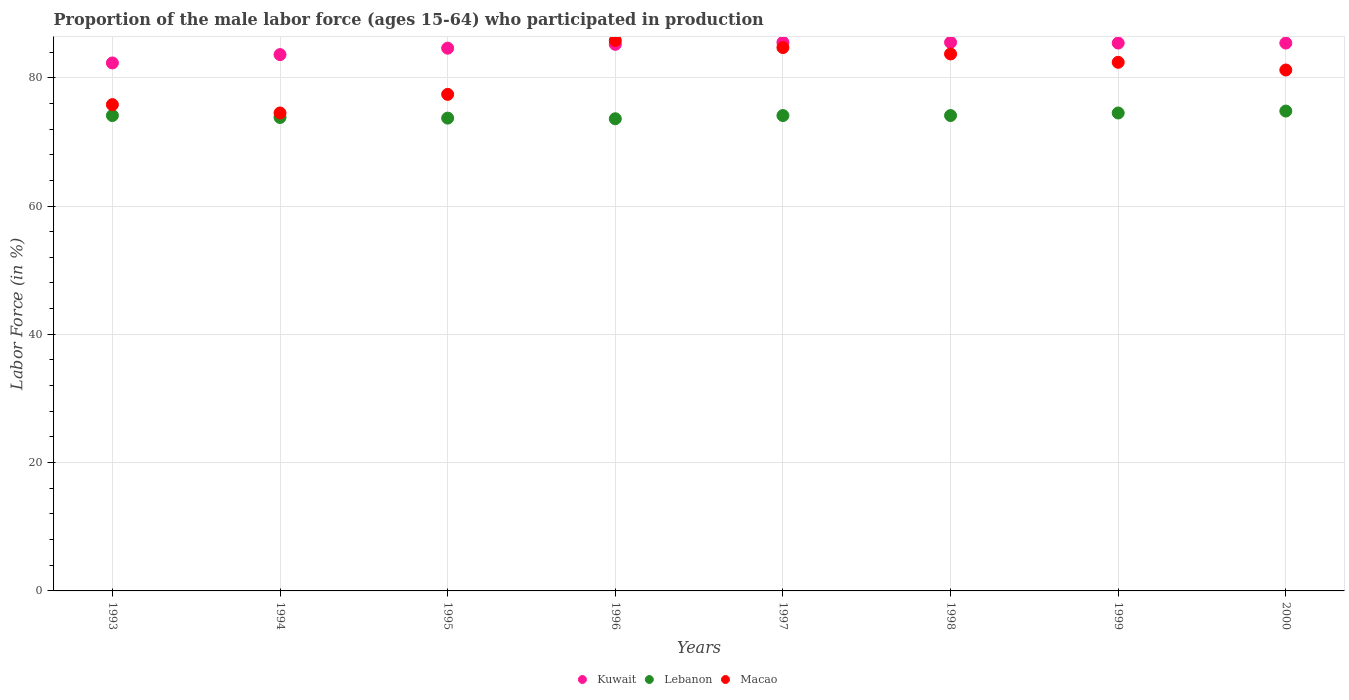How many different coloured dotlines are there?
Your response must be concise. 3. Is the number of dotlines equal to the number of legend labels?
Your response must be concise. Yes. What is the proportion of the male labor force who participated in production in Lebanon in 1998?
Your answer should be very brief. 74.1. Across all years, what is the maximum proportion of the male labor force who participated in production in Macao?
Your answer should be compact. 85.8. Across all years, what is the minimum proportion of the male labor force who participated in production in Kuwait?
Your answer should be compact. 82.3. In which year was the proportion of the male labor force who participated in production in Kuwait minimum?
Your response must be concise. 1993. What is the total proportion of the male labor force who participated in production in Macao in the graph?
Your response must be concise. 645.5. What is the difference between the proportion of the male labor force who participated in production in Lebanon in 1994 and that in 1995?
Your response must be concise. 0.1. What is the average proportion of the male labor force who participated in production in Macao per year?
Your answer should be compact. 80.69. In the year 1995, what is the difference between the proportion of the male labor force who participated in production in Kuwait and proportion of the male labor force who participated in production in Lebanon?
Provide a short and direct response. 10.9. What is the ratio of the proportion of the male labor force who participated in production in Kuwait in 1993 to that in 1994?
Provide a succinct answer. 0.98. Is the difference between the proportion of the male labor force who participated in production in Kuwait in 1994 and 1998 greater than the difference between the proportion of the male labor force who participated in production in Lebanon in 1994 and 1998?
Keep it short and to the point. No. What is the difference between the highest and the second highest proportion of the male labor force who participated in production in Kuwait?
Ensure brevity in your answer.  0. What is the difference between the highest and the lowest proportion of the male labor force who participated in production in Lebanon?
Offer a terse response. 1.2. Is the sum of the proportion of the male labor force who participated in production in Macao in 1996 and 1997 greater than the maximum proportion of the male labor force who participated in production in Kuwait across all years?
Provide a short and direct response. Yes. Is it the case that in every year, the sum of the proportion of the male labor force who participated in production in Macao and proportion of the male labor force who participated in production in Lebanon  is greater than the proportion of the male labor force who participated in production in Kuwait?
Keep it short and to the point. Yes. Does the proportion of the male labor force who participated in production in Macao monotonically increase over the years?
Offer a terse response. No. Is the proportion of the male labor force who participated in production in Macao strictly greater than the proportion of the male labor force who participated in production in Kuwait over the years?
Keep it short and to the point. No. How many dotlines are there?
Offer a very short reply. 3. How many years are there in the graph?
Your response must be concise. 8. What is the difference between two consecutive major ticks on the Y-axis?
Ensure brevity in your answer.  20. Are the values on the major ticks of Y-axis written in scientific E-notation?
Offer a terse response. No. Does the graph contain any zero values?
Your answer should be compact. No. Does the graph contain grids?
Offer a terse response. Yes. Where does the legend appear in the graph?
Provide a succinct answer. Bottom center. What is the title of the graph?
Your answer should be compact. Proportion of the male labor force (ages 15-64) who participated in production. Does "Heavily indebted poor countries" appear as one of the legend labels in the graph?
Provide a succinct answer. No. What is the label or title of the X-axis?
Your answer should be compact. Years. What is the Labor Force (in %) of Kuwait in 1993?
Your response must be concise. 82.3. What is the Labor Force (in %) in Lebanon in 1993?
Keep it short and to the point. 74.1. What is the Labor Force (in %) in Macao in 1993?
Offer a terse response. 75.8. What is the Labor Force (in %) of Kuwait in 1994?
Keep it short and to the point. 83.6. What is the Labor Force (in %) in Lebanon in 1994?
Make the answer very short. 73.8. What is the Labor Force (in %) of Macao in 1994?
Your response must be concise. 74.5. What is the Labor Force (in %) in Kuwait in 1995?
Offer a terse response. 84.6. What is the Labor Force (in %) in Lebanon in 1995?
Provide a succinct answer. 73.7. What is the Labor Force (in %) in Macao in 1995?
Make the answer very short. 77.4. What is the Labor Force (in %) in Kuwait in 1996?
Provide a succinct answer. 85.2. What is the Labor Force (in %) in Lebanon in 1996?
Offer a very short reply. 73.6. What is the Labor Force (in %) in Macao in 1996?
Offer a very short reply. 85.8. What is the Labor Force (in %) of Kuwait in 1997?
Your answer should be very brief. 85.5. What is the Labor Force (in %) in Lebanon in 1997?
Provide a succinct answer. 74.1. What is the Labor Force (in %) in Macao in 1997?
Make the answer very short. 84.7. What is the Labor Force (in %) in Kuwait in 1998?
Offer a very short reply. 85.5. What is the Labor Force (in %) in Lebanon in 1998?
Offer a very short reply. 74.1. What is the Labor Force (in %) of Macao in 1998?
Your answer should be compact. 83.7. What is the Labor Force (in %) in Kuwait in 1999?
Your answer should be very brief. 85.4. What is the Labor Force (in %) in Lebanon in 1999?
Make the answer very short. 74.5. What is the Labor Force (in %) of Macao in 1999?
Your answer should be very brief. 82.4. What is the Labor Force (in %) in Kuwait in 2000?
Make the answer very short. 85.4. What is the Labor Force (in %) of Lebanon in 2000?
Your response must be concise. 74.8. What is the Labor Force (in %) in Macao in 2000?
Make the answer very short. 81.2. Across all years, what is the maximum Labor Force (in %) of Kuwait?
Offer a very short reply. 85.5. Across all years, what is the maximum Labor Force (in %) of Lebanon?
Offer a terse response. 74.8. Across all years, what is the maximum Labor Force (in %) of Macao?
Make the answer very short. 85.8. Across all years, what is the minimum Labor Force (in %) of Kuwait?
Offer a very short reply. 82.3. Across all years, what is the minimum Labor Force (in %) in Lebanon?
Offer a very short reply. 73.6. Across all years, what is the minimum Labor Force (in %) in Macao?
Keep it short and to the point. 74.5. What is the total Labor Force (in %) in Kuwait in the graph?
Your answer should be very brief. 677.5. What is the total Labor Force (in %) in Lebanon in the graph?
Ensure brevity in your answer.  592.7. What is the total Labor Force (in %) in Macao in the graph?
Make the answer very short. 645.5. What is the difference between the Labor Force (in %) of Kuwait in 1993 and that in 1994?
Your response must be concise. -1.3. What is the difference between the Labor Force (in %) of Lebanon in 1993 and that in 1995?
Offer a terse response. 0.4. What is the difference between the Labor Force (in %) in Kuwait in 1993 and that in 1996?
Provide a short and direct response. -2.9. What is the difference between the Labor Force (in %) of Kuwait in 1993 and that in 1997?
Offer a very short reply. -3.2. What is the difference between the Labor Force (in %) of Lebanon in 1993 and that in 1997?
Provide a short and direct response. 0. What is the difference between the Labor Force (in %) in Kuwait in 1993 and that in 1998?
Give a very brief answer. -3.2. What is the difference between the Labor Force (in %) of Lebanon in 1993 and that in 1998?
Keep it short and to the point. 0. What is the difference between the Labor Force (in %) of Kuwait in 1993 and that in 2000?
Offer a very short reply. -3.1. What is the difference between the Labor Force (in %) of Macao in 1993 and that in 2000?
Provide a short and direct response. -5.4. What is the difference between the Labor Force (in %) of Lebanon in 1994 and that in 1996?
Give a very brief answer. 0.2. What is the difference between the Labor Force (in %) in Macao in 1994 and that in 1997?
Provide a succinct answer. -10.2. What is the difference between the Labor Force (in %) in Kuwait in 1994 and that in 1998?
Your response must be concise. -1.9. What is the difference between the Labor Force (in %) in Lebanon in 1994 and that in 1999?
Your answer should be very brief. -0.7. What is the difference between the Labor Force (in %) of Macao in 1994 and that in 1999?
Provide a short and direct response. -7.9. What is the difference between the Labor Force (in %) in Kuwait in 1994 and that in 2000?
Your answer should be very brief. -1.8. What is the difference between the Labor Force (in %) in Macao in 1994 and that in 2000?
Keep it short and to the point. -6.7. What is the difference between the Labor Force (in %) in Kuwait in 1995 and that in 1997?
Offer a terse response. -0.9. What is the difference between the Labor Force (in %) of Lebanon in 1995 and that in 1997?
Give a very brief answer. -0.4. What is the difference between the Labor Force (in %) in Macao in 1995 and that in 1997?
Your response must be concise. -7.3. What is the difference between the Labor Force (in %) of Kuwait in 1995 and that in 1998?
Offer a terse response. -0.9. What is the difference between the Labor Force (in %) in Lebanon in 1995 and that in 1998?
Provide a succinct answer. -0.4. What is the difference between the Labor Force (in %) in Macao in 1995 and that in 1998?
Provide a short and direct response. -6.3. What is the difference between the Labor Force (in %) of Kuwait in 1995 and that in 1999?
Your answer should be very brief. -0.8. What is the difference between the Labor Force (in %) of Macao in 1995 and that in 1999?
Provide a succinct answer. -5. What is the difference between the Labor Force (in %) in Macao in 1995 and that in 2000?
Your response must be concise. -3.8. What is the difference between the Labor Force (in %) of Lebanon in 1996 and that in 1997?
Provide a succinct answer. -0.5. What is the difference between the Labor Force (in %) in Kuwait in 1996 and that in 1999?
Ensure brevity in your answer.  -0.2. What is the difference between the Labor Force (in %) of Lebanon in 1996 and that in 1999?
Provide a succinct answer. -0.9. What is the difference between the Labor Force (in %) of Macao in 1996 and that in 1999?
Make the answer very short. 3.4. What is the difference between the Labor Force (in %) in Kuwait in 1996 and that in 2000?
Your answer should be very brief. -0.2. What is the difference between the Labor Force (in %) of Lebanon in 1996 and that in 2000?
Make the answer very short. -1.2. What is the difference between the Labor Force (in %) in Macao in 1996 and that in 2000?
Give a very brief answer. 4.6. What is the difference between the Labor Force (in %) in Kuwait in 1997 and that in 1999?
Make the answer very short. 0.1. What is the difference between the Labor Force (in %) of Lebanon in 1997 and that in 1999?
Offer a terse response. -0.4. What is the difference between the Labor Force (in %) of Macao in 1997 and that in 1999?
Offer a very short reply. 2.3. What is the difference between the Labor Force (in %) of Lebanon in 1997 and that in 2000?
Provide a short and direct response. -0.7. What is the difference between the Labor Force (in %) in Macao in 1997 and that in 2000?
Offer a very short reply. 3.5. What is the difference between the Labor Force (in %) in Kuwait in 1998 and that in 1999?
Your response must be concise. 0.1. What is the difference between the Labor Force (in %) of Macao in 1998 and that in 1999?
Make the answer very short. 1.3. What is the difference between the Labor Force (in %) of Kuwait in 1998 and that in 2000?
Make the answer very short. 0.1. What is the difference between the Labor Force (in %) of Lebanon in 1999 and that in 2000?
Provide a short and direct response. -0.3. What is the difference between the Labor Force (in %) of Kuwait in 1993 and the Labor Force (in %) of Lebanon in 1995?
Make the answer very short. 8.6. What is the difference between the Labor Force (in %) in Lebanon in 1993 and the Labor Force (in %) in Macao in 1995?
Provide a succinct answer. -3.3. What is the difference between the Labor Force (in %) in Kuwait in 1993 and the Labor Force (in %) in Macao in 1996?
Offer a terse response. -3.5. What is the difference between the Labor Force (in %) of Lebanon in 1993 and the Labor Force (in %) of Macao in 1996?
Provide a succinct answer. -11.7. What is the difference between the Labor Force (in %) of Kuwait in 1993 and the Labor Force (in %) of Lebanon in 1997?
Keep it short and to the point. 8.2. What is the difference between the Labor Force (in %) of Lebanon in 1993 and the Labor Force (in %) of Macao in 1997?
Offer a terse response. -10.6. What is the difference between the Labor Force (in %) in Kuwait in 1993 and the Labor Force (in %) in Macao in 1998?
Give a very brief answer. -1.4. What is the difference between the Labor Force (in %) in Lebanon in 1993 and the Labor Force (in %) in Macao in 1998?
Your answer should be compact. -9.6. What is the difference between the Labor Force (in %) of Kuwait in 1993 and the Labor Force (in %) of Lebanon in 1999?
Ensure brevity in your answer.  7.8. What is the difference between the Labor Force (in %) of Lebanon in 1993 and the Labor Force (in %) of Macao in 2000?
Offer a terse response. -7.1. What is the difference between the Labor Force (in %) of Kuwait in 1994 and the Labor Force (in %) of Lebanon in 1995?
Offer a very short reply. 9.9. What is the difference between the Labor Force (in %) in Kuwait in 1994 and the Labor Force (in %) in Macao in 1995?
Your response must be concise. 6.2. What is the difference between the Labor Force (in %) in Kuwait in 1994 and the Labor Force (in %) in Lebanon in 1996?
Give a very brief answer. 10. What is the difference between the Labor Force (in %) of Kuwait in 1994 and the Labor Force (in %) of Macao in 1996?
Provide a short and direct response. -2.2. What is the difference between the Labor Force (in %) in Kuwait in 1994 and the Labor Force (in %) in Lebanon in 1997?
Your response must be concise. 9.5. What is the difference between the Labor Force (in %) of Lebanon in 1994 and the Labor Force (in %) of Macao in 1997?
Provide a succinct answer. -10.9. What is the difference between the Labor Force (in %) of Kuwait in 1994 and the Labor Force (in %) of Lebanon in 1999?
Keep it short and to the point. 9.1. What is the difference between the Labor Force (in %) in Kuwait in 1994 and the Labor Force (in %) in Macao in 1999?
Offer a terse response. 1.2. What is the difference between the Labor Force (in %) of Lebanon in 1994 and the Labor Force (in %) of Macao in 1999?
Your response must be concise. -8.6. What is the difference between the Labor Force (in %) of Lebanon in 1994 and the Labor Force (in %) of Macao in 2000?
Make the answer very short. -7.4. What is the difference between the Labor Force (in %) of Kuwait in 1995 and the Labor Force (in %) of Lebanon in 1996?
Your answer should be very brief. 11. What is the difference between the Labor Force (in %) in Kuwait in 1995 and the Labor Force (in %) in Macao in 1996?
Make the answer very short. -1.2. What is the difference between the Labor Force (in %) of Lebanon in 1995 and the Labor Force (in %) of Macao in 1996?
Give a very brief answer. -12.1. What is the difference between the Labor Force (in %) of Kuwait in 1995 and the Labor Force (in %) of Macao in 1997?
Your response must be concise. -0.1. What is the difference between the Labor Force (in %) of Lebanon in 1995 and the Labor Force (in %) of Macao in 1997?
Give a very brief answer. -11. What is the difference between the Labor Force (in %) of Kuwait in 1995 and the Labor Force (in %) of Lebanon in 1998?
Give a very brief answer. 10.5. What is the difference between the Labor Force (in %) in Kuwait in 1995 and the Labor Force (in %) in Macao in 1998?
Give a very brief answer. 0.9. What is the difference between the Labor Force (in %) of Kuwait in 1996 and the Labor Force (in %) of Lebanon in 1997?
Provide a short and direct response. 11.1. What is the difference between the Labor Force (in %) in Kuwait in 1996 and the Labor Force (in %) in Lebanon in 1998?
Provide a succinct answer. 11.1. What is the difference between the Labor Force (in %) in Kuwait in 1996 and the Labor Force (in %) in Macao in 1998?
Your response must be concise. 1.5. What is the difference between the Labor Force (in %) in Kuwait in 1996 and the Labor Force (in %) in Lebanon in 1999?
Your answer should be very brief. 10.7. What is the difference between the Labor Force (in %) of Kuwait in 1996 and the Labor Force (in %) of Macao in 1999?
Offer a terse response. 2.8. What is the difference between the Labor Force (in %) of Lebanon in 1996 and the Labor Force (in %) of Macao in 1999?
Your answer should be very brief. -8.8. What is the difference between the Labor Force (in %) of Kuwait in 1996 and the Labor Force (in %) of Lebanon in 2000?
Offer a terse response. 10.4. What is the difference between the Labor Force (in %) of Kuwait in 1996 and the Labor Force (in %) of Macao in 2000?
Offer a terse response. 4. What is the difference between the Labor Force (in %) in Kuwait in 1997 and the Labor Force (in %) in Lebanon in 1998?
Your answer should be very brief. 11.4. What is the difference between the Labor Force (in %) of Kuwait in 1997 and the Labor Force (in %) of Macao in 1998?
Make the answer very short. 1.8. What is the difference between the Labor Force (in %) in Lebanon in 1997 and the Labor Force (in %) in Macao in 1998?
Make the answer very short. -9.6. What is the difference between the Labor Force (in %) of Kuwait in 1997 and the Labor Force (in %) of Lebanon in 1999?
Your answer should be compact. 11. What is the difference between the Labor Force (in %) in Lebanon in 1997 and the Labor Force (in %) in Macao in 2000?
Provide a short and direct response. -7.1. What is the difference between the Labor Force (in %) in Kuwait in 1998 and the Labor Force (in %) in Lebanon in 1999?
Your answer should be compact. 11. What is the difference between the Labor Force (in %) in Kuwait in 1998 and the Labor Force (in %) in Macao in 1999?
Keep it short and to the point. 3.1. What is the difference between the Labor Force (in %) of Lebanon in 1998 and the Labor Force (in %) of Macao in 1999?
Your answer should be very brief. -8.3. What is the difference between the Labor Force (in %) in Kuwait in 1998 and the Labor Force (in %) in Lebanon in 2000?
Give a very brief answer. 10.7. What is the difference between the Labor Force (in %) in Lebanon in 1998 and the Labor Force (in %) in Macao in 2000?
Offer a terse response. -7.1. What is the difference between the Labor Force (in %) of Kuwait in 1999 and the Labor Force (in %) of Lebanon in 2000?
Make the answer very short. 10.6. What is the difference between the Labor Force (in %) in Kuwait in 1999 and the Labor Force (in %) in Macao in 2000?
Provide a short and direct response. 4.2. What is the average Labor Force (in %) in Kuwait per year?
Ensure brevity in your answer.  84.69. What is the average Labor Force (in %) in Lebanon per year?
Provide a short and direct response. 74.09. What is the average Labor Force (in %) in Macao per year?
Your answer should be very brief. 80.69. In the year 1993, what is the difference between the Labor Force (in %) in Kuwait and Labor Force (in %) in Lebanon?
Ensure brevity in your answer.  8.2. In the year 1993, what is the difference between the Labor Force (in %) of Kuwait and Labor Force (in %) of Macao?
Keep it short and to the point. 6.5. In the year 1993, what is the difference between the Labor Force (in %) in Lebanon and Labor Force (in %) in Macao?
Offer a terse response. -1.7. In the year 1994, what is the difference between the Labor Force (in %) of Kuwait and Labor Force (in %) of Lebanon?
Your answer should be very brief. 9.8. In the year 1994, what is the difference between the Labor Force (in %) of Kuwait and Labor Force (in %) of Macao?
Your answer should be very brief. 9.1. In the year 1994, what is the difference between the Labor Force (in %) of Lebanon and Labor Force (in %) of Macao?
Keep it short and to the point. -0.7. In the year 1995, what is the difference between the Labor Force (in %) of Kuwait and Labor Force (in %) of Macao?
Give a very brief answer. 7.2. In the year 1995, what is the difference between the Labor Force (in %) of Lebanon and Labor Force (in %) of Macao?
Ensure brevity in your answer.  -3.7. In the year 1996, what is the difference between the Labor Force (in %) in Kuwait and Labor Force (in %) in Lebanon?
Offer a terse response. 11.6. In the year 1996, what is the difference between the Labor Force (in %) in Kuwait and Labor Force (in %) in Macao?
Keep it short and to the point. -0.6. In the year 1996, what is the difference between the Labor Force (in %) of Lebanon and Labor Force (in %) of Macao?
Give a very brief answer. -12.2. In the year 1997, what is the difference between the Labor Force (in %) in Kuwait and Labor Force (in %) in Lebanon?
Provide a succinct answer. 11.4. What is the ratio of the Labor Force (in %) in Kuwait in 1993 to that in 1994?
Your answer should be very brief. 0.98. What is the ratio of the Labor Force (in %) of Lebanon in 1993 to that in 1994?
Provide a succinct answer. 1. What is the ratio of the Labor Force (in %) in Macao in 1993 to that in 1994?
Offer a very short reply. 1.02. What is the ratio of the Labor Force (in %) in Kuwait in 1993 to that in 1995?
Provide a succinct answer. 0.97. What is the ratio of the Labor Force (in %) in Lebanon in 1993 to that in 1995?
Keep it short and to the point. 1.01. What is the ratio of the Labor Force (in %) of Macao in 1993 to that in 1995?
Your answer should be compact. 0.98. What is the ratio of the Labor Force (in %) of Kuwait in 1993 to that in 1996?
Your response must be concise. 0.97. What is the ratio of the Labor Force (in %) of Lebanon in 1993 to that in 1996?
Offer a terse response. 1.01. What is the ratio of the Labor Force (in %) in Macao in 1993 to that in 1996?
Provide a short and direct response. 0.88. What is the ratio of the Labor Force (in %) of Kuwait in 1993 to that in 1997?
Offer a terse response. 0.96. What is the ratio of the Labor Force (in %) in Lebanon in 1993 to that in 1997?
Offer a very short reply. 1. What is the ratio of the Labor Force (in %) of Macao in 1993 to that in 1997?
Keep it short and to the point. 0.89. What is the ratio of the Labor Force (in %) of Kuwait in 1993 to that in 1998?
Offer a terse response. 0.96. What is the ratio of the Labor Force (in %) in Lebanon in 1993 to that in 1998?
Provide a short and direct response. 1. What is the ratio of the Labor Force (in %) of Macao in 1993 to that in 1998?
Provide a succinct answer. 0.91. What is the ratio of the Labor Force (in %) in Kuwait in 1993 to that in 1999?
Make the answer very short. 0.96. What is the ratio of the Labor Force (in %) in Lebanon in 1993 to that in 1999?
Make the answer very short. 0.99. What is the ratio of the Labor Force (in %) in Macao in 1993 to that in 1999?
Your answer should be very brief. 0.92. What is the ratio of the Labor Force (in %) of Kuwait in 1993 to that in 2000?
Give a very brief answer. 0.96. What is the ratio of the Labor Force (in %) in Lebanon in 1993 to that in 2000?
Your answer should be compact. 0.99. What is the ratio of the Labor Force (in %) of Macao in 1993 to that in 2000?
Make the answer very short. 0.93. What is the ratio of the Labor Force (in %) of Macao in 1994 to that in 1995?
Provide a succinct answer. 0.96. What is the ratio of the Labor Force (in %) in Kuwait in 1994 to that in 1996?
Give a very brief answer. 0.98. What is the ratio of the Labor Force (in %) in Lebanon in 1994 to that in 1996?
Keep it short and to the point. 1. What is the ratio of the Labor Force (in %) in Macao in 1994 to that in 1996?
Give a very brief answer. 0.87. What is the ratio of the Labor Force (in %) in Kuwait in 1994 to that in 1997?
Provide a succinct answer. 0.98. What is the ratio of the Labor Force (in %) in Lebanon in 1994 to that in 1997?
Your response must be concise. 1. What is the ratio of the Labor Force (in %) of Macao in 1994 to that in 1997?
Give a very brief answer. 0.88. What is the ratio of the Labor Force (in %) in Kuwait in 1994 to that in 1998?
Your answer should be very brief. 0.98. What is the ratio of the Labor Force (in %) of Macao in 1994 to that in 1998?
Make the answer very short. 0.89. What is the ratio of the Labor Force (in %) of Kuwait in 1994 to that in 1999?
Keep it short and to the point. 0.98. What is the ratio of the Labor Force (in %) in Lebanon in 1994 to that in 1999?
Your answer should be compact. 0.99. What is the ratio of the Labor Force (in %) of Macao in 1994 to that in 1999?
Your answer should be very brief. 0.9. What is the ratio of the Labor Force (in %) in Kuwait in 1994 to that in 2000?
Keep it short and to the point. 0.98. What is the ratio of the Labor Force (in %) of Lebanon in 1994 to that in 2000?
Offer a very short reply. 0.99. What is the ratio of the Labor Force (in %) in Macao in 1994 to that in 2000?
Ensure brevity in your answer.  0.92. What is the ratio of the Labor Force (in %) of Kuwait in 1995 to that in 1996?
Offer a terse response. 0.99. What is the ratio of the Labor Force (in %) in Lebanon in 1995 to that in 1996?
Make the answer very short. 1. What is the ratio of the Labor Force (in %) of Macao in 1995 to that in 1996?
Give a very brief answer. 0.9. What is the ratio of the Labor Force (in %) in Kuwait in 1995 to that in 1997?
Offer a terse response. 0.99. What is the ratio of the Labor Force (in %) in Lebanon in 1995 to that in 1997?
Offer a very short reply. 0.99. What is the ratio of the Labor Force (in %) in Macao in 1995 to that in 1997?
Keep it short and to the point. 0.91. What is the ratio of the Labor Force (in %) in Kuwait in 1995 to that in 1998?
Offer a very short reply. 0.99. What is the ratio of the Labor Force (in %) in Lebanon in 1995 to that in 1998?
Your answer should be very brief. 0.99. What is the ratio of the Labor Force (in %) of Macao in 1995 to that in 1998?
Offer a very short reply. 0.92. What is the ratio of the Labor Force (in %) of Kuwait in 1995 to that in 1999?
Your answer should be very brief. 0.99. What is the ratio of the Labor Force (in %) of Lebanon in 1995 to that in 1999?
Your answer should be very brief. 0.99. What is the ratio of the Labor Force (in %) of Macao in 1995 to that in 1999?
Offer a very short reply. 0.94. What is the ratio of the Labor Force (in %) in Kuwait in 1995 to that in 2000?
Make the answer very short. 0.99. What is the ratio of the Labor Force (in %) of Lebanon in 1995 to that in 2000?
Give a very brief answer. 0.99. What is the ratio of the Labor Force (in %) in Macao in 1995 to that in 2000?
Make the answer very short. 0.95. What is the ratio of the Labor Force (in %) of Kuwait in 1996 to that in 1997?
Offer a terse response. 1. What is the ratio of the Labor Force (in %) of Macao in 1996 to that in 1997?
Provide a succinct answer. 1.01. What is the ratio of the Labor Force (in %) of Kuwait in 1996 to that in 1998?
Your answer should be very brief. 1. What is the ratio of the Labor Force (in %) of Macao in 1996 to that in 1998?
Your answer should be compact. 1.03. What is the ratio of the Labor Force (in %) in Kuwait in 1996 to that in 1999?
Your answer should be very brief. 1. What is the ratio of the Labor Force (in %) in Lebanon in 1996 to that in 1999?
Ensure brevity in your answer.  0.99. What is the ratio of the Labor Force (in %) in Macao in 1996 to that in 1999?
Offer a very short reply. 1.04. What is the ratio of the Labor Force (in %) in Macao in 1996 to that in 2000?
Make the answer very short. 1.06. What is the ratio of the Labor Force (in %) of Macao in 1997 to that in 1998?
Your answer should be compact. 1.01. What is the ratio of the Labor Force (in %) in Macao in 1997 to that in 1999?
Your answer should be very brief. 1.03. What is the ratio of the Labor Force (in %) of Lebanon in 1997 to that in 2000?
Ensure brevity in your answer.  0.99. What is the ratio of the Labor Force (in %) in Macao in 1997 to that in 2000?
Offer a terse response. 1.04. What is the ratio of the Labor Force (in %) in Lebanon in 1998 to that in 1999?
Your answer should be compact. 0.99. What is the ratio of the Labor Force (in %) in Macao in 1998 to that in 1999?
Ensure brevity in your answer.  1.02. What is the ratio of the Labor Force (in %) in Kuwait in 1998 to that in 2000?
Offer a very short reply. 1. What is the ratio of the Labor Force (in %) in Lebanon in 1998 to that in 2000?
Your response must be concise. 0.99. What is the ratio of the Labor Force (in %) of Macao in 1998 to that in 2000?
Your response must be concise. 1.03. What is the ratio of the Labor Force (in %) in Kuwait in 1999 to that in 2000?
Your answer should be very brief. 1. What is the ratio of the Labor Force (in %) in Macao in 1999 to that in 2000?
Your answer should be very brief. 1.01. What is the difference between the highest and the second highest Labor Force (in %) in Lebanon?
Keep it short and to the point. 0.3. What is the difference between the highest and the lowest Labor Force (in %) in Kuwait?
Offer a terse response. 3.2. What is the difference between the highest and the lowest Labor Force (in %) in Lebanon?
Your answer should be compact. 1.2. 